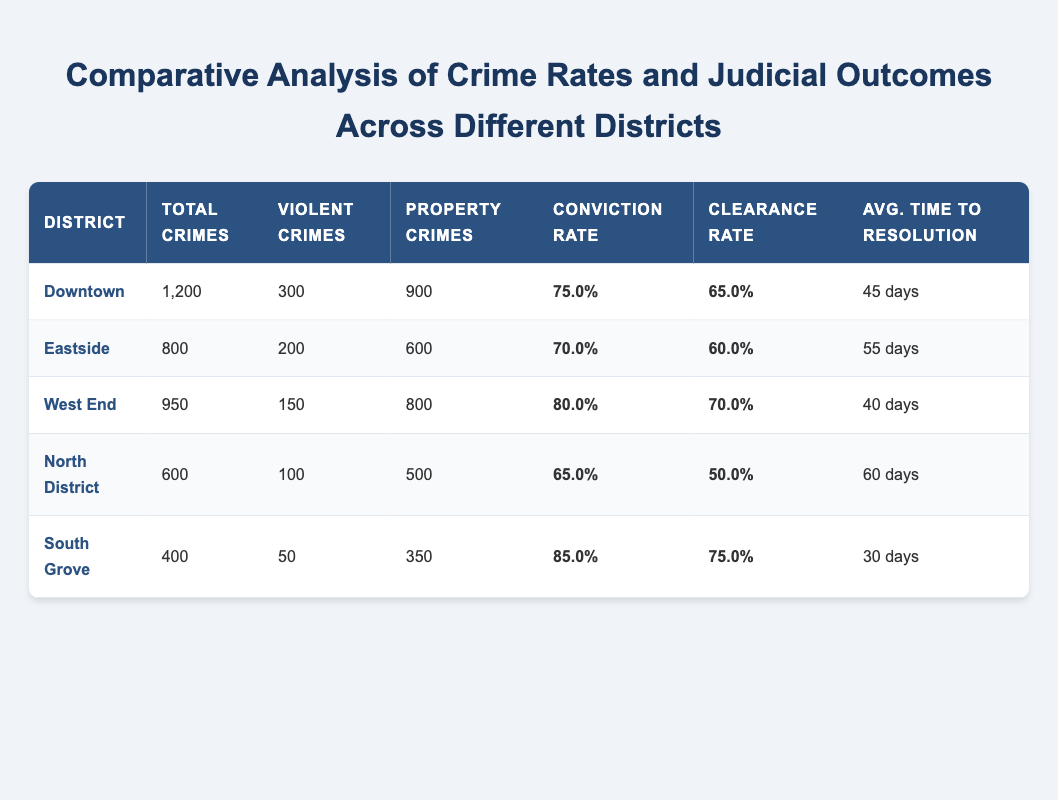What is the total number of crimes reported in the Downtown district? The table states that the total crimes reported in the Downtown district is listed directly under the "Total Crimes" column for that district, which shows 1200.
Answer: 1200 Which district has the highest conviction rate? By examining the "Conviction Rate" column for all districts, the South Grove district shows a conviction rate of 85.0, which is the highest among all districts.
Answer: South Grove What is the average conviction rate across all districts? To find the average conviction rate, we sum the conviction rates (75.0 + 70.0 + 80.0 + 65.0 + 85.0 = 375.0) and divide by the number of districts (375.0 / 5 = 75.0).
Answer: 75.0 Are there more property crimes than violent crimes in the West End district? In the West End district, there are 800 property crimes and 150 violent crimes. Since 800 is greater than 150, it is confirmed that there are more property crimes than violent crimes.
Answer: Yes Which district has the least average time to resolution? By reviewing the "Avg. Time to Resolution" column, the South Grove district has the least time at 30 days, which is lower than any other district's average time.
Answer: South Grove How many total crimes were reported in the North District compared to the South Grove district? The North District reported 600 total crimes, while the South Grove district reported 400 total crimes. Since 600 is greater than 400, we confirm that the North District has more crimes reported than the South Grove district.
Answer: North District What is the difference in clearance rates between Downtown and Eastside? The clearance rate for Downtown is 65.0, and for Eastside it is 60.0. Therefore, the difference is calculated as 65.0 - 60.0 = 5.0.
Answer: 5.0 In which district does the average time to resolution exceed 50 days? By checking the "Avg. Time to Resolution" for each district, we see that both Eastside (55 days) and North District (60 days) exceed 50 days.
Answer: Eastside, North District Is the total number of violent crimes in the South Grove district higher than that in North District? The South Grove district has 50 violent crimes, while the North District has 100. Thus, since 50 is less than 100, the total number of violent crimes in South Grove is not higher.
Answer: No 